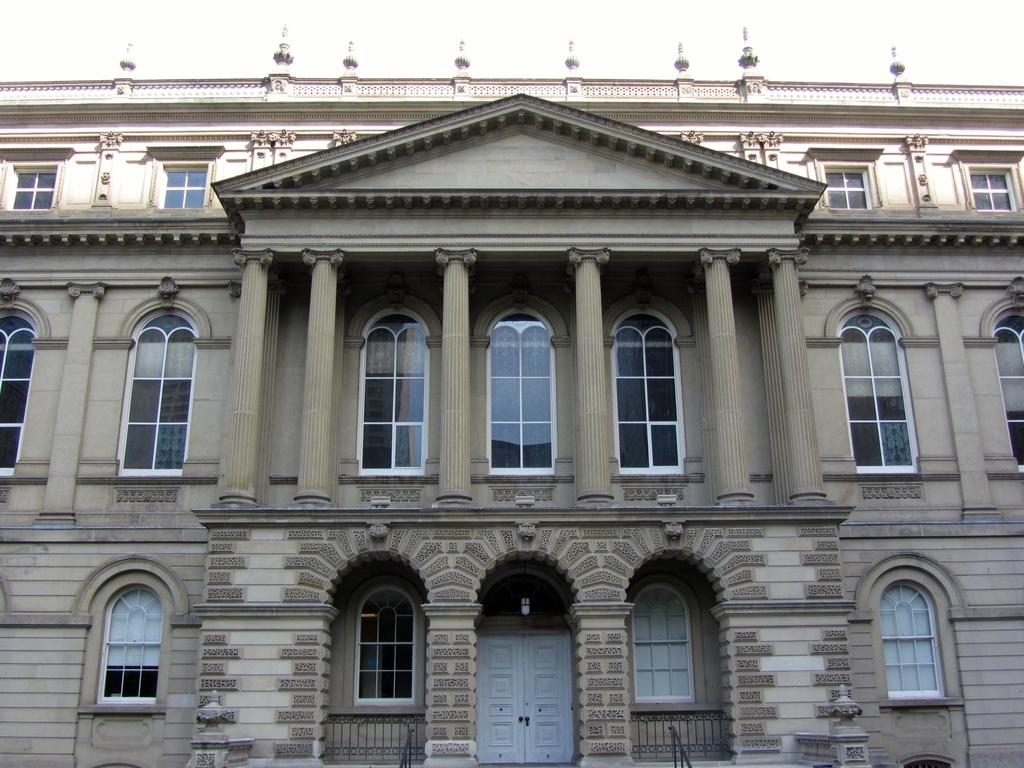What is the main subject of the image? The main subject of the image is the front view of a building. What can be seen above the building in the image? The sky is visible at the top of the image. What is the tendency of the crows in the image? There are no crows present in the image, so it is not possible to determine their tendency. 